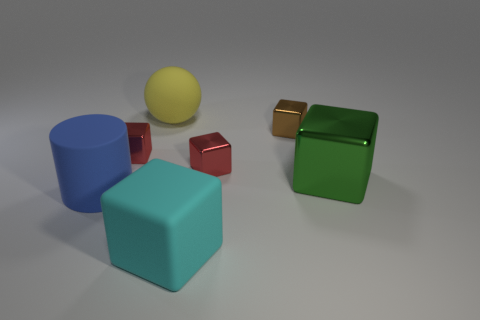There is a large object that is behind the big blue rubber object and left of the big metal block; what is its material?
Give a very brief answer. Rubber. There is a large metal thing in front of the tiny red metallic object that is right of the cyan rubber block; are there any balls that are in front of it?
Provide a short and direct response. No. Is there any other thing that has the same material as the large cylinder?
Your answer should be compact. Yes. There is a brown object that is the same material as the green object; what is its shape?
Make the answer very short. Cube. Are there fewer rubber cylinders that are to the left of the cylinder than brown metal cubes that are right of the large metal block?
Your answer should be very brief. No. How many tiny objects are either green objects or matte cylinders?
Make the answer very short. 0. There is a matte object that is behind the big green metallic object; is its shape the same as the red shiny thing that is on the left side of the yellow sphere?
Provide a succinct answer. No. How big is the metal thing on the left side of the big cube on the left side of the metal thing that is right of the brown metallic object?
Your answer should be compact. Small. There is a matte object on the right side of the big rubber ball; what size is it?
Offer a terse response. Large. There is a tiny red thing that is on the right side of the large yellow matte object; what is it made of?
Offer a terse response. Metal. 